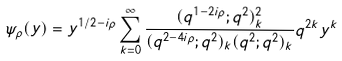Convert formula to latex. <formula><loc_0><loc_0><loc_500><loc_500>\psi _ { \rho } ( y ) = y ^ { 1 / 2 - i \rho } \sum _ { k = 0 } ^ { \infty } \frac { ( q ^ { 1 - 2 i \rho } ; q ^ { 2 } ) ^ { 2 } _ { k } } { ( q ^ { 2 - 4 i \rho } ; q ^ { 2 } ) _ { k } ( q ^ { 2 } ; q ^ { 2 } ) _ { k } } q ^ { 2 k } y ^ { k }</formula> 